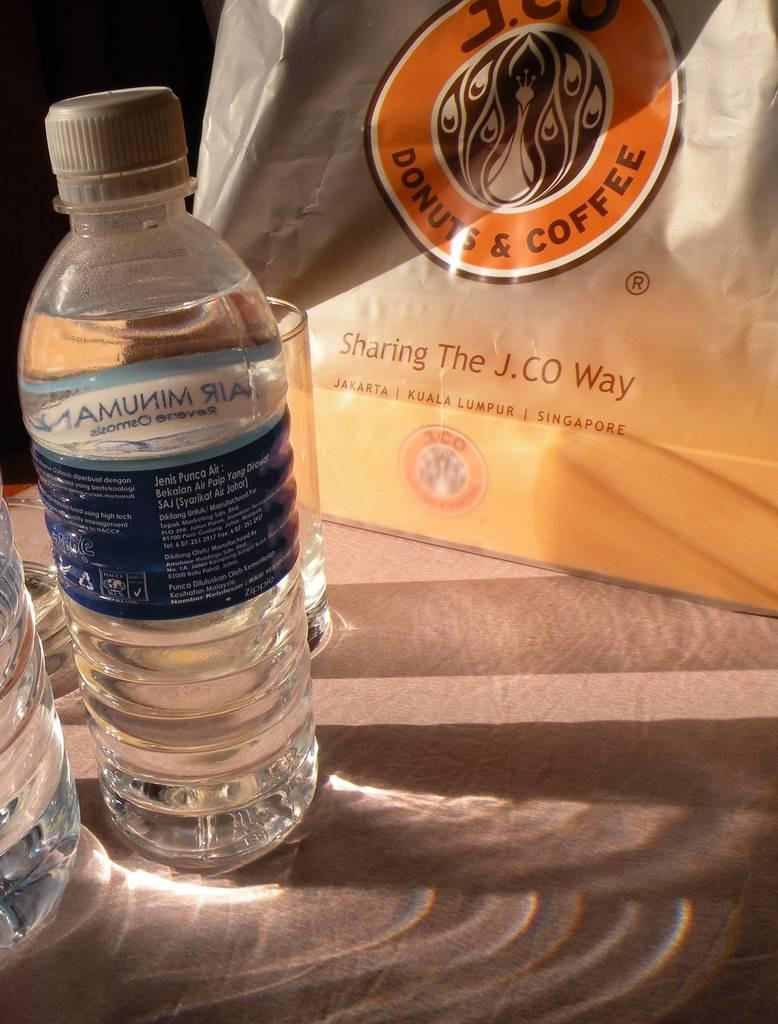<image>
Relay a brief, clear account of the picture shown. A bottle of water is in front of a bag that reads "Sharing the J.CO Way" 